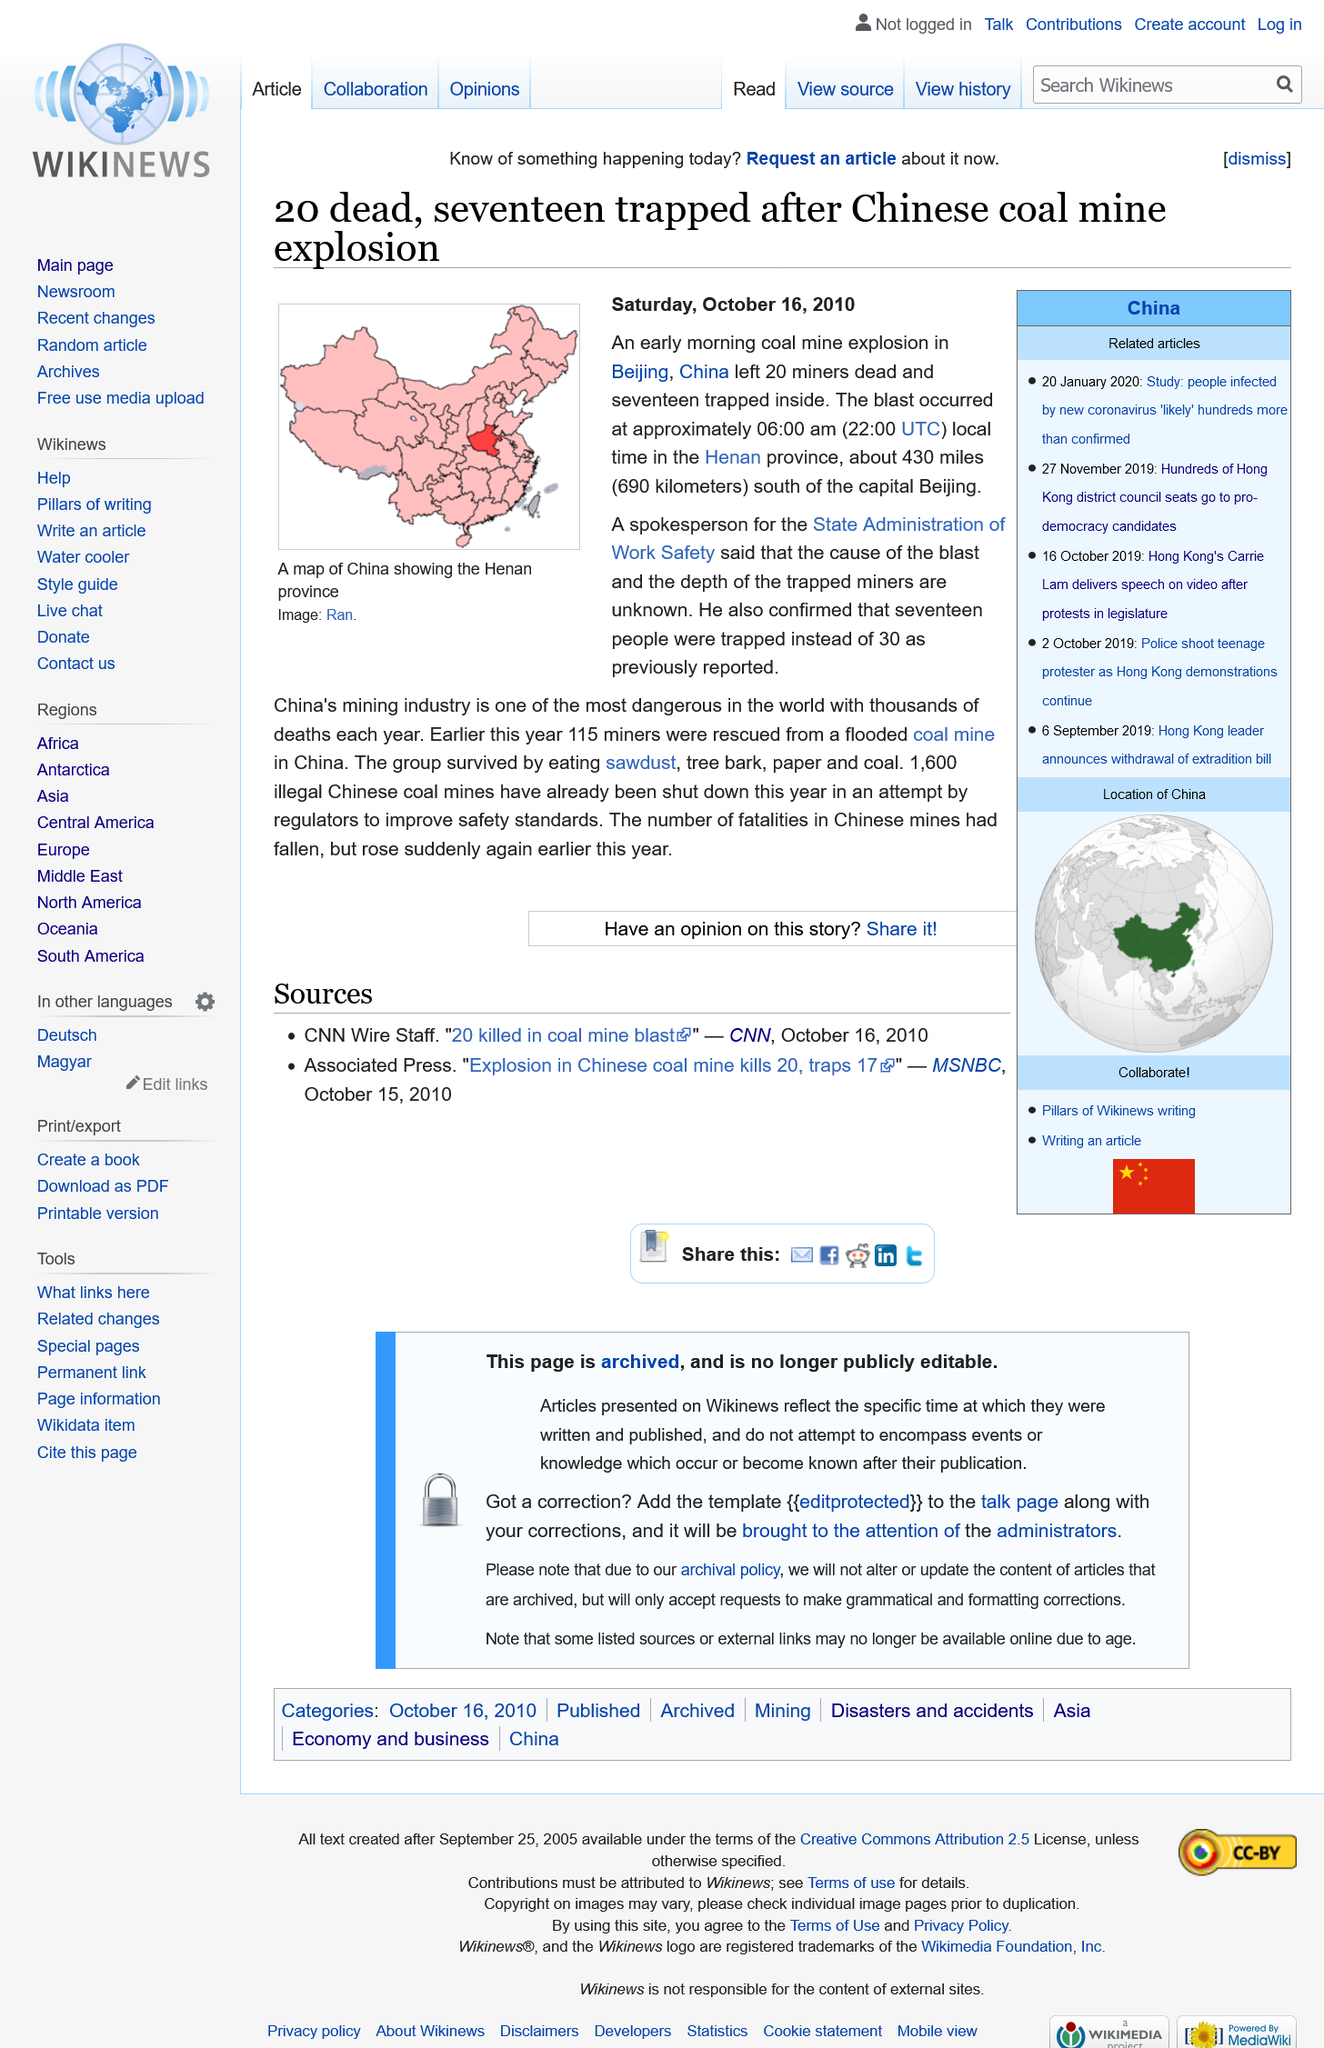Give some essential details in this illustration. Seventeen miners were trapped inside the mine. It is reported that 20 miners have died as a result of the explosion. 